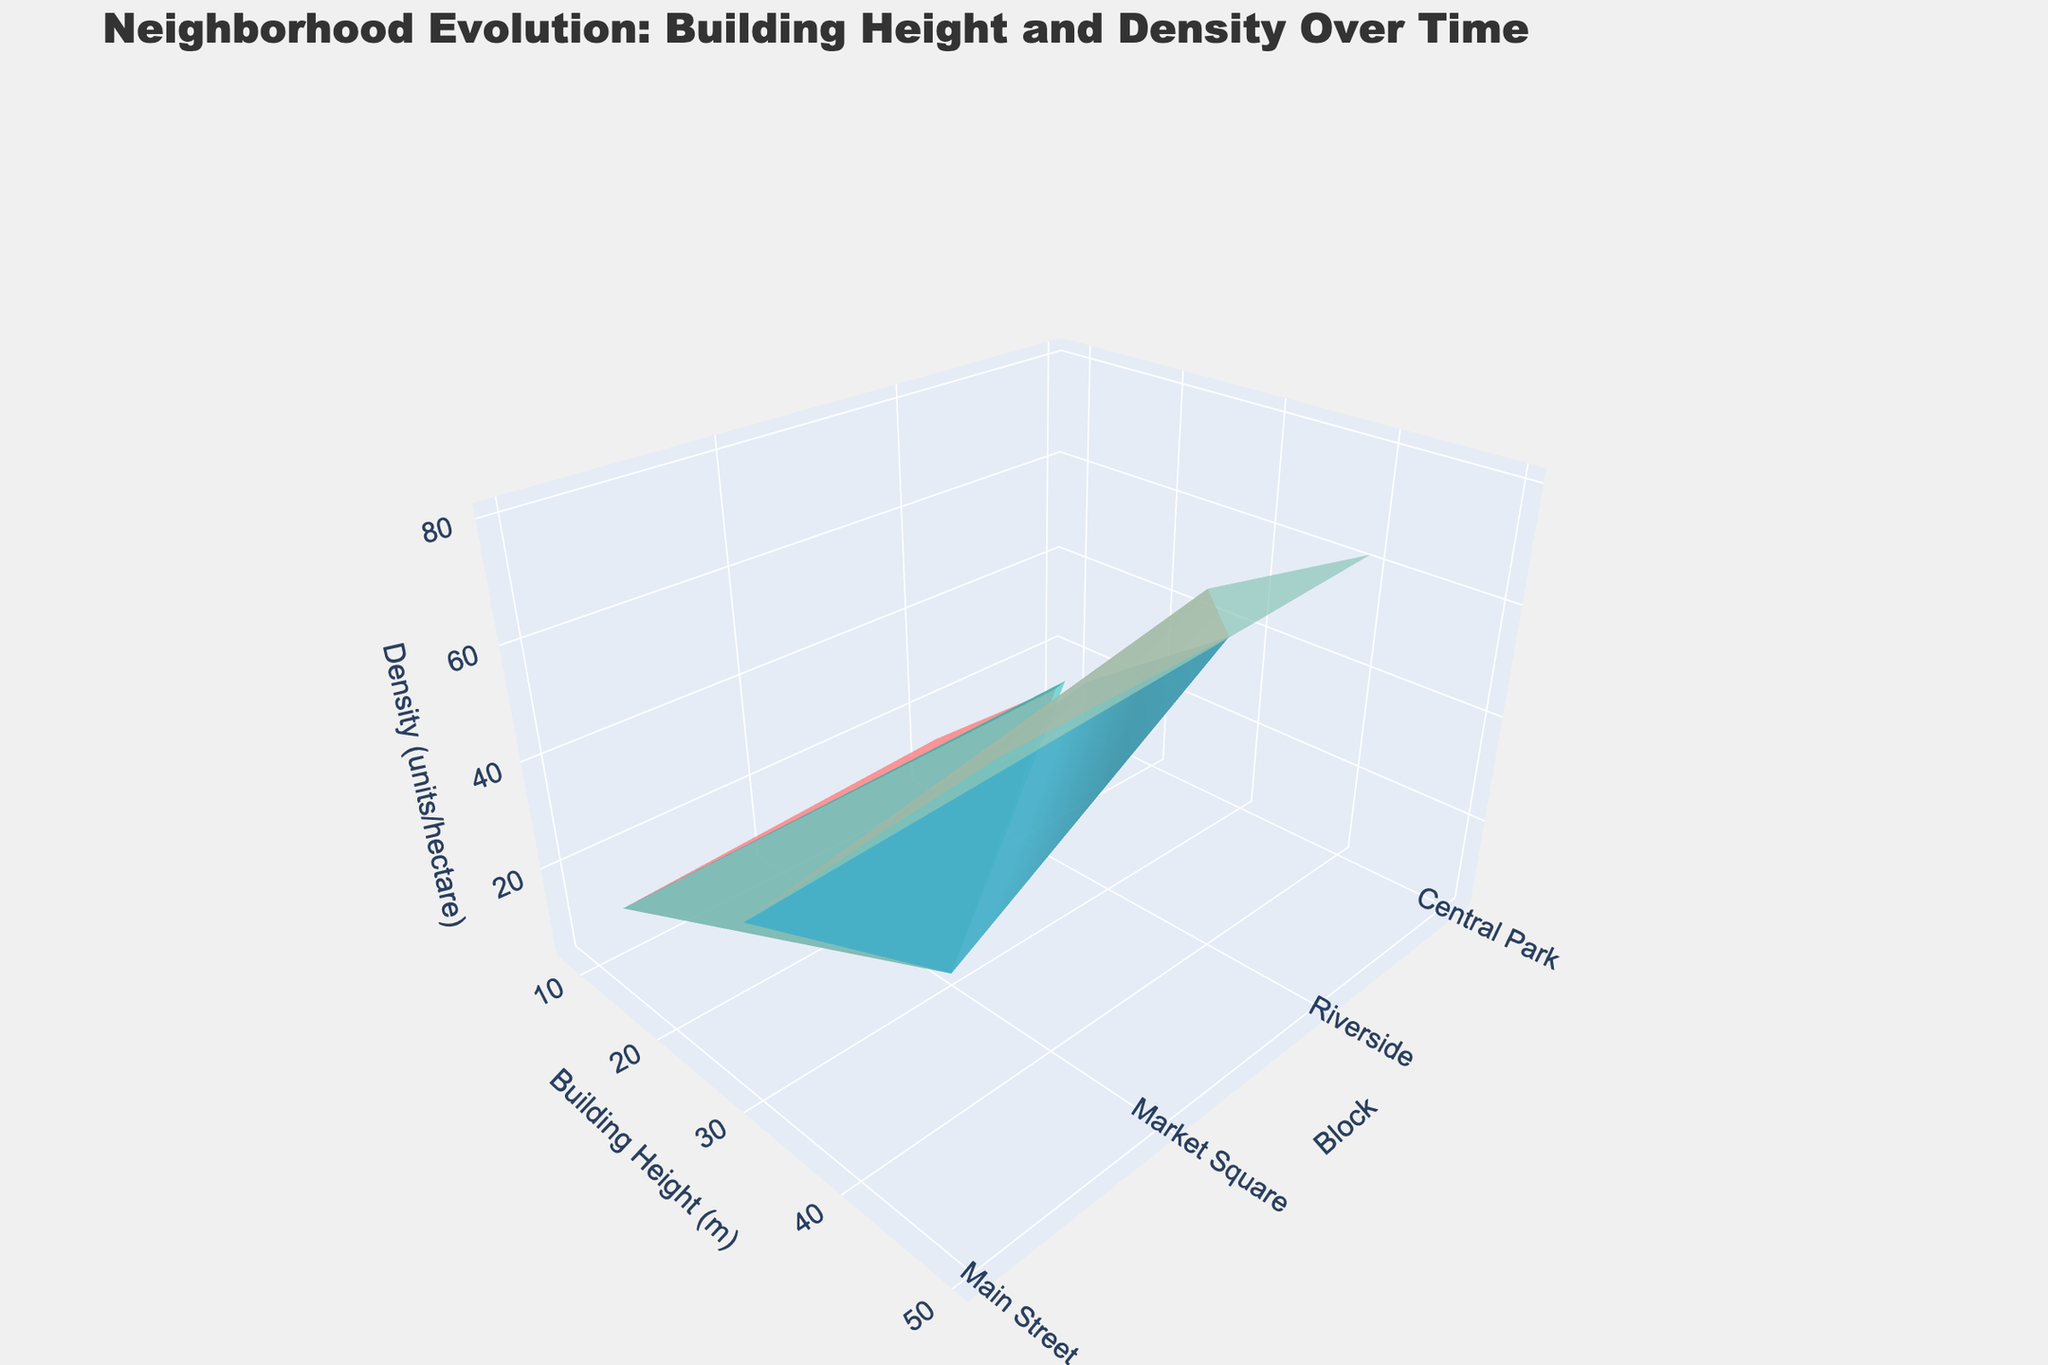How many years are represented in the plot? The plot shows data for multiple years, each represented by a different color in the plot. By examining the legend, we can see that there are five distinct years: 2000, 2005, 2010, 2015, and 2020.
Answer: 5 What is the tallest building in 2020, and how tall is it? By analyzing the building heights for 2020 along the x-axis, the tallest building can be seen in the block with the highest x-coordinate value. The tallest building in 2020 is "Riverside Mixed-Use Development," which has a height of 50 meters.
Answer: 50 meters Which block had the highest density in 2015, and what was the density? Looking at the z-axis for 2015 data points, the highest density can be found in the color-coded area corresponding to that year. "Riverside" had the highest density in 2015, with a density of 60 units per hectare.
Answer: 60 units per hectare Between which two years did "Riverside" see the largest increase in building height? By comparing building heights for "Riverside" between subsequent years, the largest increase in height can be seen by looking at the tallest points. The largest increase in building height occurred between 2005 (25 meters) and 2010 (40 meters), with an increase of 15 meters.
Answer: 2005 and 2010 How does the building density in "Central Park" in 2005 compare to that in 2020? To compare densities, we look at the z-axis values for "Central Park" in 2005 and 2020. In 2005, the density for "Central Park" was 10 units per hectare, while in 2020, it was 45 units per hectare, showing an increase.
Answer: 10 units per hectare in 2005, 45 units per hectare in 2020 What is the average building height for "Market Square" across all years presented? To find the average, sum the building heights for "Market Square" in each year: (30+30+30+35+35) meters, giving a total of 160 meters. Dividing by the number of years (5), the average building height is 32 meters.
Answer: 32 meters In which year did "Main Street" see an introduction of a new building instead of the continued existence of an older one? By following the buildings listed for "Main Street" across years, the transition from "Old Town Hall" to "City Hall Complex" appears in 2010. This change indicates 2010 as the year for the introduction of a new building.
Answer: 2010 Which year has the most consistent building heights across all blocks, and what does this indicate about the development trend? Consistency can be identified where building heights vary the least. In 2000 and 2005, heights were relatively similar, with most buildings except one being below 15 meters. This suggests a period of minimal height variation and slower growth.
Answer: 2000 What trend can be observed in the density units per hectare from 2000 to 2020 in "Riverside"? By examining the z-axis values for "Riverside" from 2000 to 2020, we see that the density increases progressively: 15 in 2000, 40 in 2005, 60 in 2010, 60 in 2015, and 80 in 2020. This indicates a strong upward trend in building density in "Riverside."
Answer: Increasing trend 